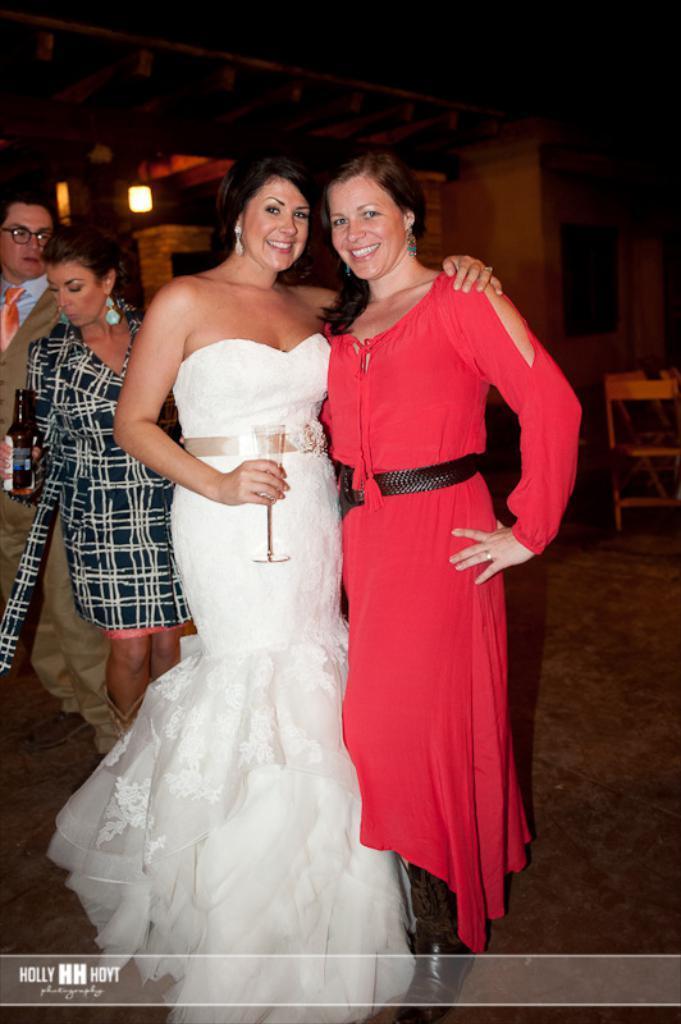Could you give a brief overview of what you see in this image? This picture shows few woman standing and we see a woman holding a glass in the hand and another woman holding bottle in her hand and we see light and a chair and we see a watermark on the bottom left corner and we see a man standing and we see spectacles on his face. 